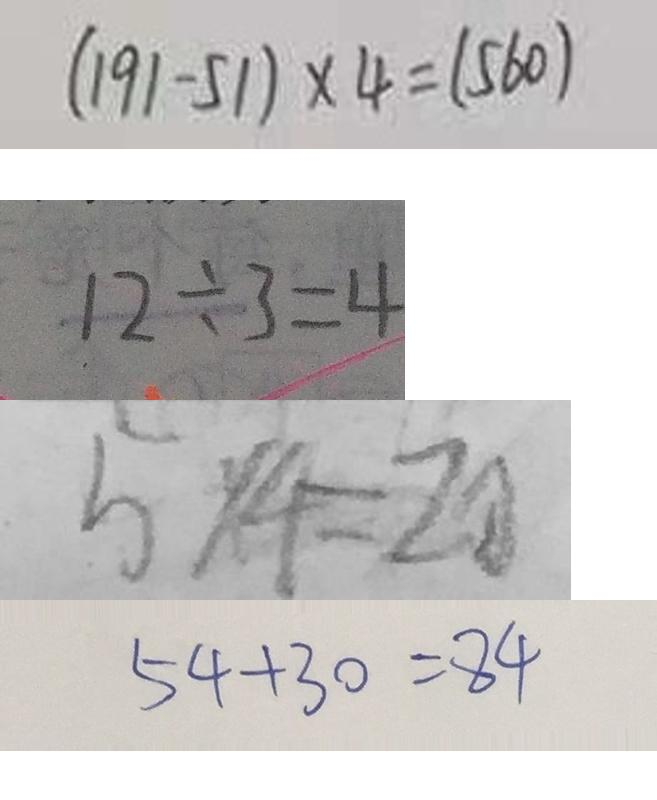Convert formula to latex. <formula><loc_0><loc_0><loc_500><loc_500>( 1 9 1 - 5 1 ) \times 4 = ( 5 6 0 ) 
 1 2 \div 3 = 4 
 5 \times 4 = 2 0 
 5 4 + 3 0 = 8 4</formula> 